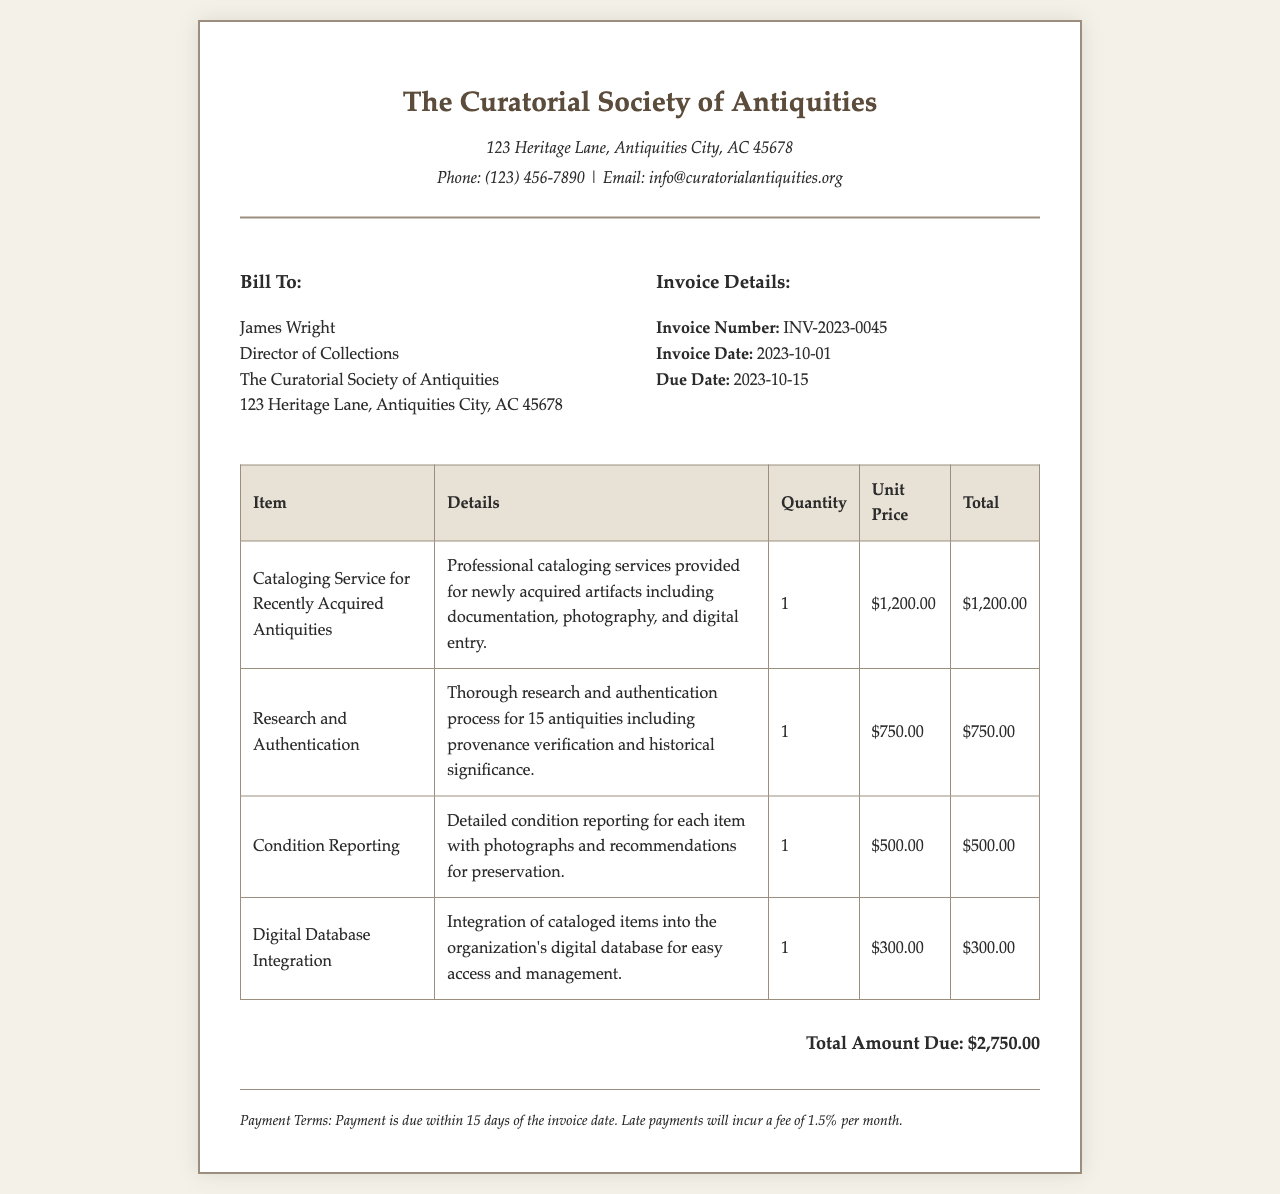What is the invoice number? The invoice number is a unique identifier for tracking and referencing the invoice, which is visible in the document.
Answer: INV-2023-0045 What is the due date for the invoice? The due date indicates when payment is expected and is specified in the invoice.
Answer: 2023-10-15 Who is the bill recipient? The bill recipient identifies the individual or organization responsible for payment as shown in the document.
Answer: James Wright What is the total amount due? The total amount due represents the overall charge for the services rendered, calculated from the items listed.
Answer: $2,750.00 How many services are listed in the invoice? Counting the distinct services provided in the invoice gives an overview of the offerings.
Answer: 4 What service involves digital database integration? This question requires understanding which specific item relates to integrating cataloged items, as stated in the invoice.
Answer: Digital Database Integration What is the payment term mentioned in the document? The payment term outlines the time frame in which the payment should be made, specified in the invoice.
Answer: 15 days What is included under the details for the "Research and Authentication"? This requires reasoning to identify the specifics of that service mentioned within the invoice.
Answer: Provenance verification and historical significance What is the unit price for the condition reporting service? The unit price for each service details the individual charge for that specific offering in the invoice.
Answer: $500.00 